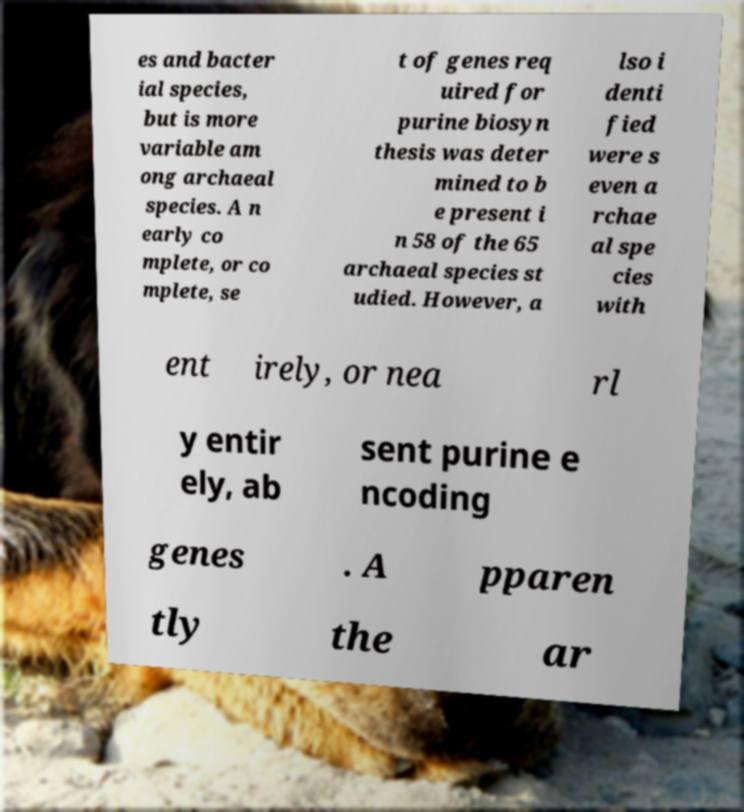Please read and relay the text visible in this image. What does it say? es and bacter ial species, but is more variable am ong archaeal species. A n early co mplete, or co mplete, se t of genes req uired for purine biosyn thesis was deter mined to b e present i n 58 of the 65 archaeal species st udied. However, a lso i denti fied were s even a rchae al spe cies with ent irely, or nea rl y entir ely, ab sent purine e ncoding genes . A pparen tly the ar 